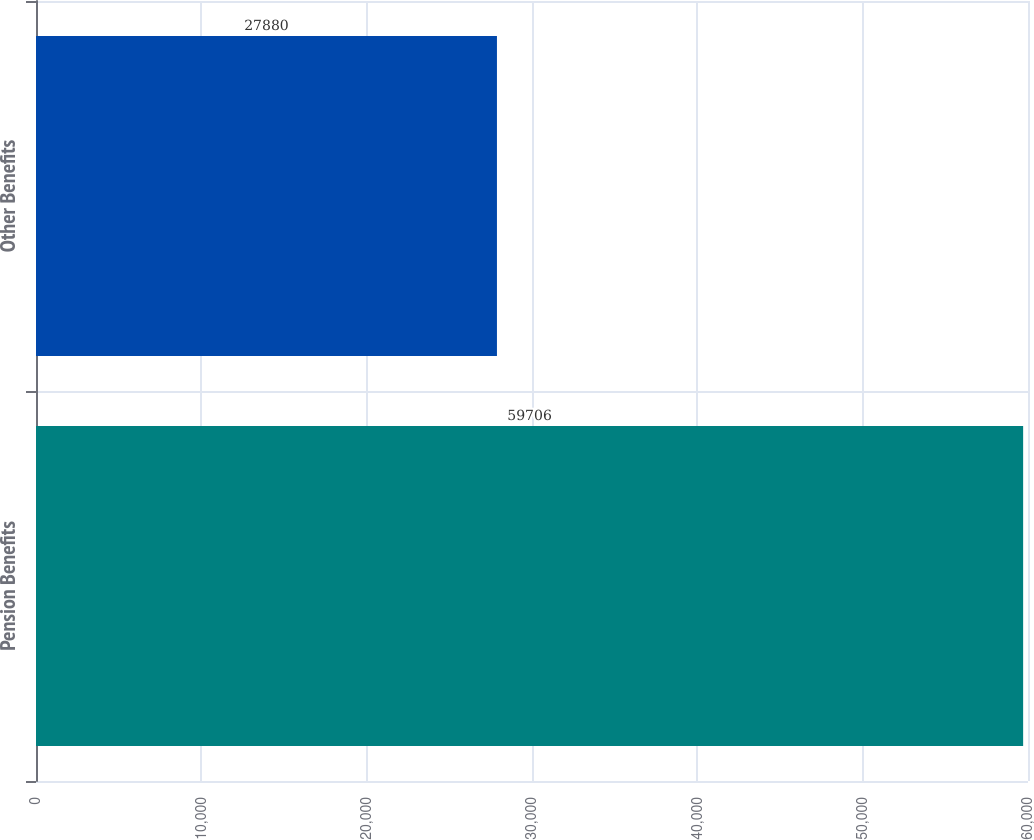<chart> <loc_0><loc_0><loc_500><loc_500><bar_chart><fcel>Pension Benefits<fcel>Other Benefits<nl><fcel>59706<fcel>27880<nl></chart> 